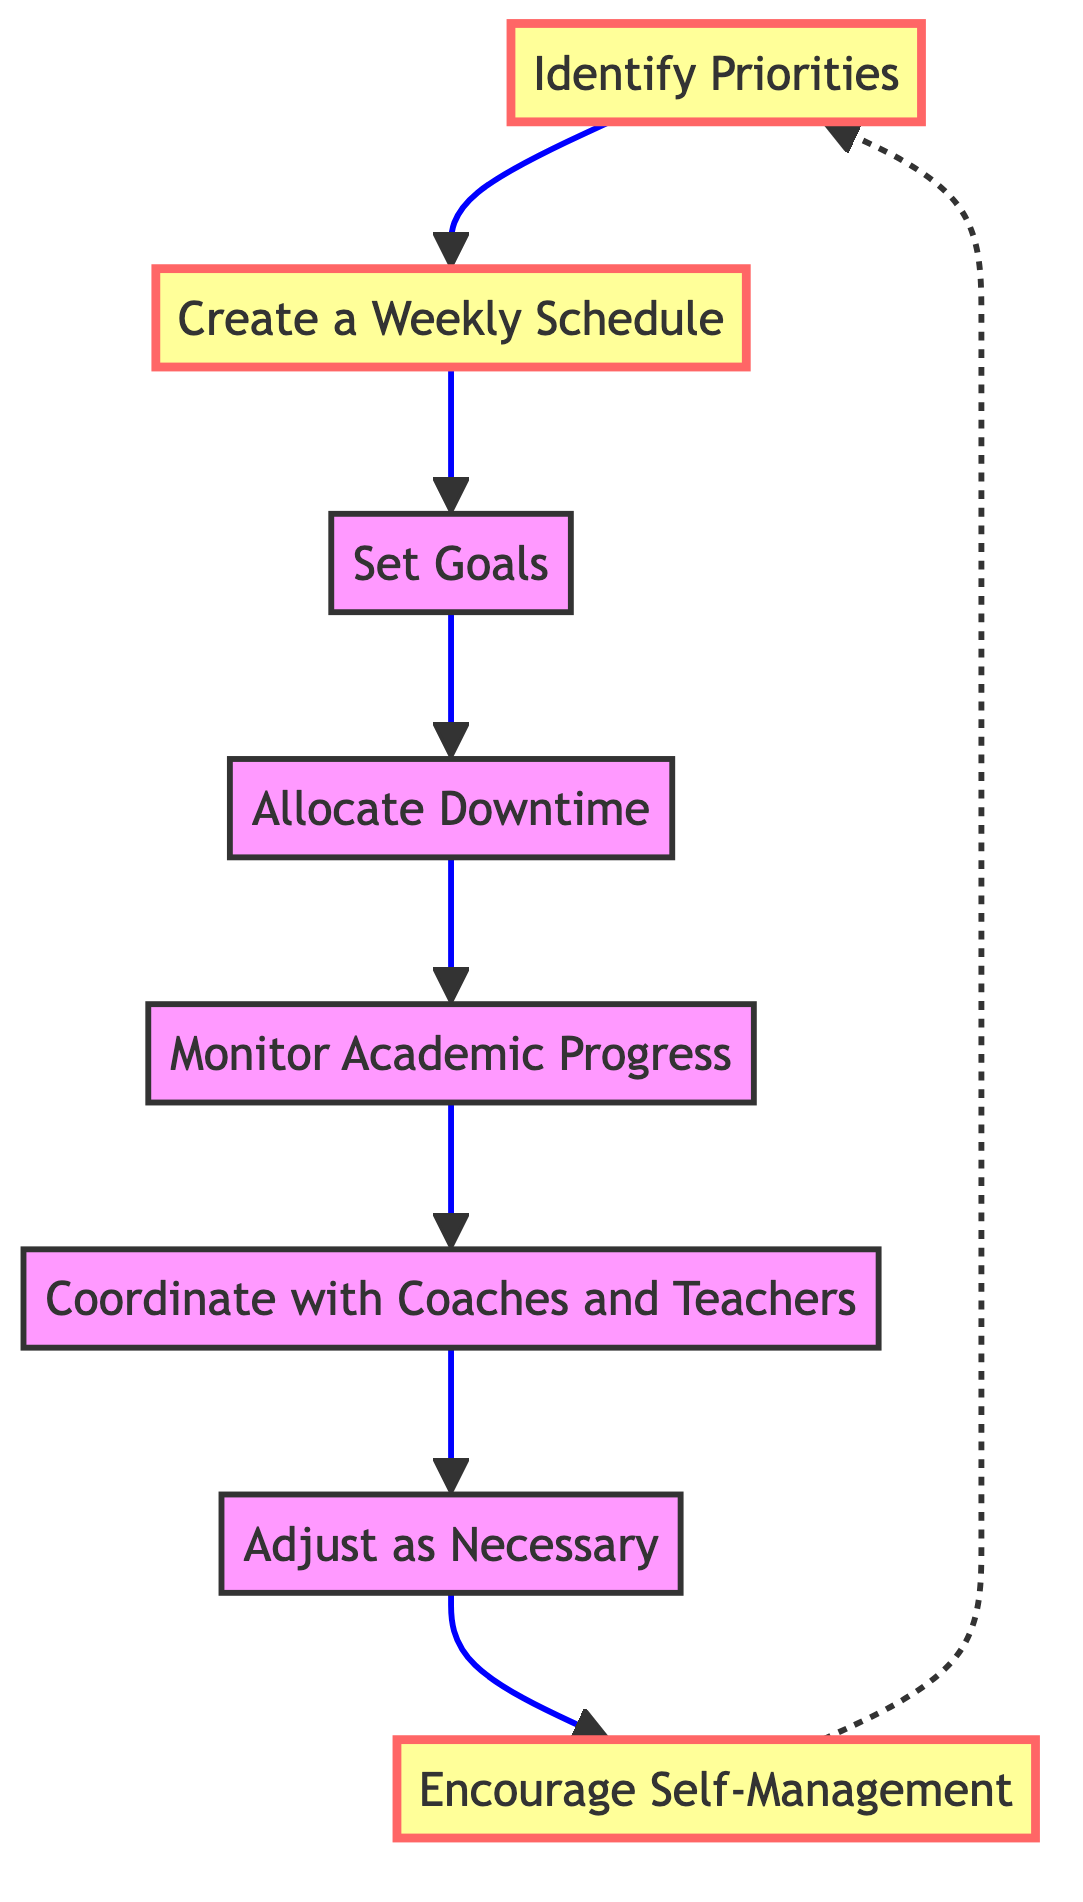What is the first step in managing school and sports activities? The flow chart indicates that the first step is "Identify Priorities." This step involves discussing with each child to understand their school and sports commitments and preferences.
Answer: Identify Priorities How many steps are there in total? By counting the nodes listed in the flow chart, there are a total of eight steps in the process of managing school and sports activities.
Answer: Eight What is the last step in the flow chart? The last step in the flow chart is "Encourage Self-Management," which focuses on teaching children to manage their own time effectively and be responsible for their commitments.
Answer: Encourage Self-Management Which step comes after "Set Goals"? The step that follows "Set Goals" in the flow chart is "Allocate Downtime," indicating the importance of ensuring sufficient rest and relaxation to prevent burnout.
Answer: Allocate Downtime How is "Coordinate with Coaches and Teachers" connected to the previous steps? "Coordinate with Coaches and Teachers" is connected to the previous step "Monitor Academic Progress," showing that after overseeing academic performance, it is crucial to stay in touch with coaches and teachers for insights and updates.
Answer: Monitor Academic Progress What do you need to do after "Allocate Downtime"? After "Allocate Downtime," the next action is to "Monitor Academic Progress," which emphasizes regular checking of homework, grades, and school feedback for informed academic performance.
Answer: Monitor Academic Progress What is the relationship between "Encourage Self-Management" and "Identify Priorities"? "Encourage Self-Management" leads back to "Identify Priorities" in a dashed line, suggesting a cyclical relationship where teaching children to self-manage may influence priority identification on an ongoing basis.
Answer: Cyclical relationship What is the significance of the dashed line in the flow chart? The dashed line indicates a feedback mechanism in the flow chart, connecting "Encourage Self-Management" back to "Identify Priorities," suggesting that as children learn to manage their time, it may lead to re-evaluating their priorities.
Answer: Feedback mechanism 